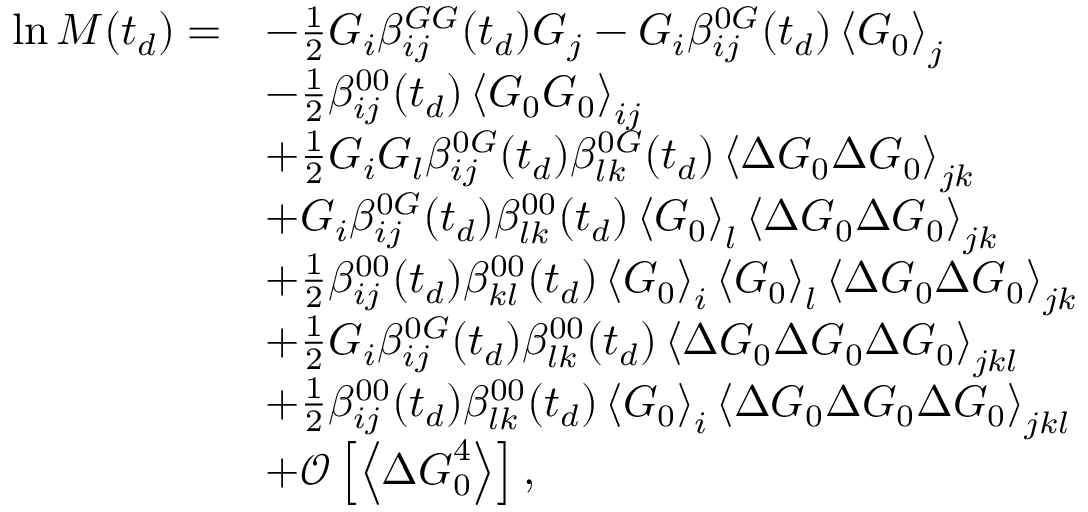Convert formula to latex. <formula><loc_0><loc_0><loc_500><loc_500>\begin{array} { r l } { \ln M ( t _ { d } ) = } & { - \frac { 1 } { 2 } G _ { i } \beta _ { i j } ^ { G G } ( t _ { d } ) G _ { j } - G _ { i } \beta _ { i j } ^ { 0 G } ( t _ { d } ) \left \langle G _ { 0 } \right \rangle _ { j } } \\ & { - \frac { 1 } { 2 } \beta _ { i j } ^ { 0 0 } ( t _ { d } ) \left \langle G _ { 0 } G _ { 0 } \right \rangle _ { i j } } \\ & { + \frac { 1 } { 2 } G _ { i } G _ { l } \beta _ { i j } ^ { 0 G } ( t _ { d } ) \beta _ { l k } ^ { 0 G } ( t _ { d } ) \left \langle \Delta G _ { 0 } \Delta G _ { 0 } \right \rangle _ { j k } } \\ & { + G _ { i } \beta _ { i j } ^ { 0 G } ( t _ { d } ) \beta _ { l k } ^ { 0 0 } ( t _ { d } ) \left \langle G _ { 0 } \right \rangle _ { l } \left \langle \Delta G _ { 0 } \Delta G _ { 0 } \right \rangle _ { j k } } \\ & { + \frac { 1 } { 2 } \beta _ { i j } ^ { 0 0 } ( t _ { d } ) \beta _ { k l } ^ { 0 0 } ( t _ { d } ) \left \langle G _ { 0 } \right \rangle _ { i } \left \langle G _ { 0 } \right \rangle _ { l } \left \langle \Delta G _ { 0 } \Delta G _ { 0 } \right \rangle _ { j k } } \\ & { + \frac { 1 } { 2 } G _ { i } \beta _ { i j } ^ { 0 G } ( t _ { d } ) \beta _ { l k } ^ { 0 0 } ( t _ { d } ) \left \langle \Delta G _ { 0 } \Delta G _ { 0 } \Delta G _ { 0 } \right \rangle _ { j k l } } \\ & { + \frac { 1 } { 2 } \beta _ { i j } ^ { 0 0 } ( t _ { d } ) \beta _ { l k } ^ { 0 0 } ( t _ { d } ) \left \langle G _ { 0 } \right \rangle _ { i } \left \langle \Delta G _ { 0 } \Delta G _ { 0 } \Delta G _ { 0 } \right \rangle _ { j k l } } \\ & { + \mathcal { O } \left [ \left \langle \Delta G _ { 0 } ^ { 4 } \right \rangle \right ] , } \end{array}</formula> 